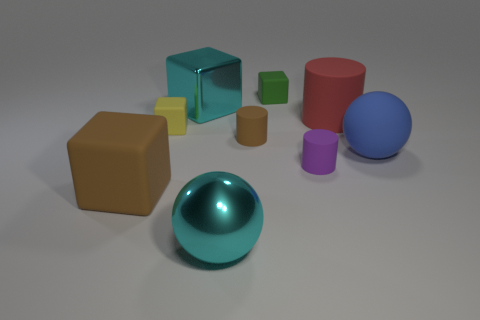What number of other objects are the same material as the red thing?
Your response must be concise. 6. What is the shape of the brown object in front of the large ball right of the matte cube that is behind the big red matte cylinder?
Offer a very short reply. Cube. Are there fewer large matte cylinders in front of the brown cylinder than red matte objects that are on the right side of the big matte cube?
Ensure brevity in your answer.  Yes. Are there any large cylinders of the same color as the big rubber sphere?
Your answer should be compact. No. Is the material of the purple cylinder the same as the block that is in front of the large blue matte thing?
Provide a short and direct response. Yes. Are there any tiny cylinders that are behind the shiny thing behind the big metallic sphere?
Ensure brevity in your answer.  No. There is a large rubber object that is in front of the big red matte object and to the left of the rubber sphere; what color is it?
Provide a succinct answer. Brown. How big is the shiny cube?
Your answer should be compact. Large. How many red rubber objects have the same size as the yellow thing?
Offer a terse response. 0. Do the big cube in front of the red rubber cylinder and the tiny object in front of the blue rubber thing have the same material?
Keep it short and to the point. Yes. 